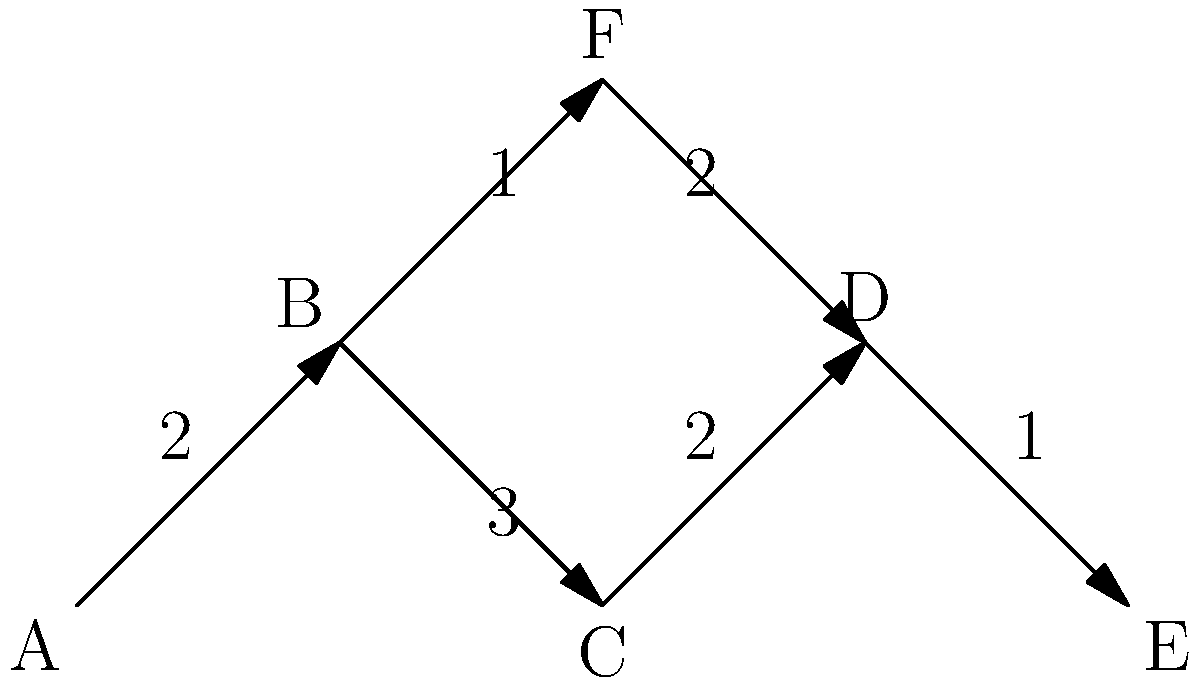In the given metabolic network diagram, determine the shortest path from metabolite A to metabolite E. What is the total weight of this path? To find the shortest path from A to E, we need to consider all possible paths and their total weights:

1. Path A → B → C → D → E:
   Weight = 2 + 3 + 2 + 1 = 8

2. Path A → B → F → D → E:
   Weight = 2 + 1 + 2 + 1 = 6

We compare the total weights of these paths:

- Path 1: 8
- Path 2: 6

The shortest path is the one with the lowest total weight, which is Path 2 (A → B → F → D → E) with a total weight of 6.
Answer: 6 